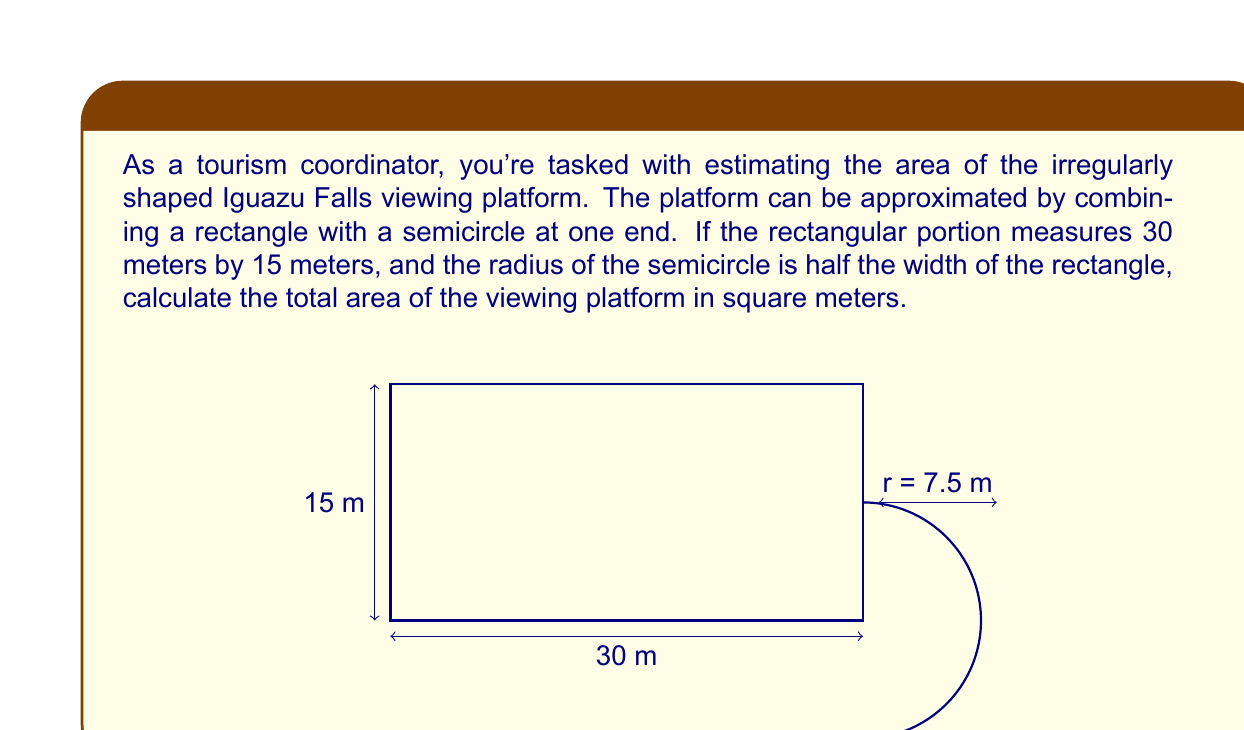Can you solve this math problem? Let's approach this problem step by step:

1) First, we need to calculate the area of the rectangular portion:
   $A_{rectangle} = length \times width$
   $A_{rectangle} = 30 \text{ m} \times 15 \text{ m} = 450 \text{ m}^2$

2) Now, we need to find the area of the semicircle:
   - The radius of the semicircle is half the width of the rectangle:
     $r = 15 \text{ m} \div 2 = 7.5 \text{ m}$
   - The area of a full circle is $\pi r^2$, so the area of a semicircle is half of that:
     $A_{semicircle} = \frac{1}{2} \pi r^2$
     $A_{semicircle} = \frac{1}{2} \pi (7.5 \text{ m})^2$
     $A_{semicircle} = \frac{1}{2} \pi (56.25 \text{ m}^2)$
     $A_{semicircle} \approx 88.36 \text{ m}^2$

3) The total area is the sum of the rectangular area and the semicircular area:
   $A_{total} = A_{rectangle} + A_{semicircle}$
   $A_{total} = 450 \text{ m}^2 + 88.36 \text{ m}^2$
   $A_{total} \approx 538.36 \text{ m}^2$

Therefore, the total area of the viewing platform is approximately 538.36 square meters.
Answer: $538.36 \text{ m}^2$ 